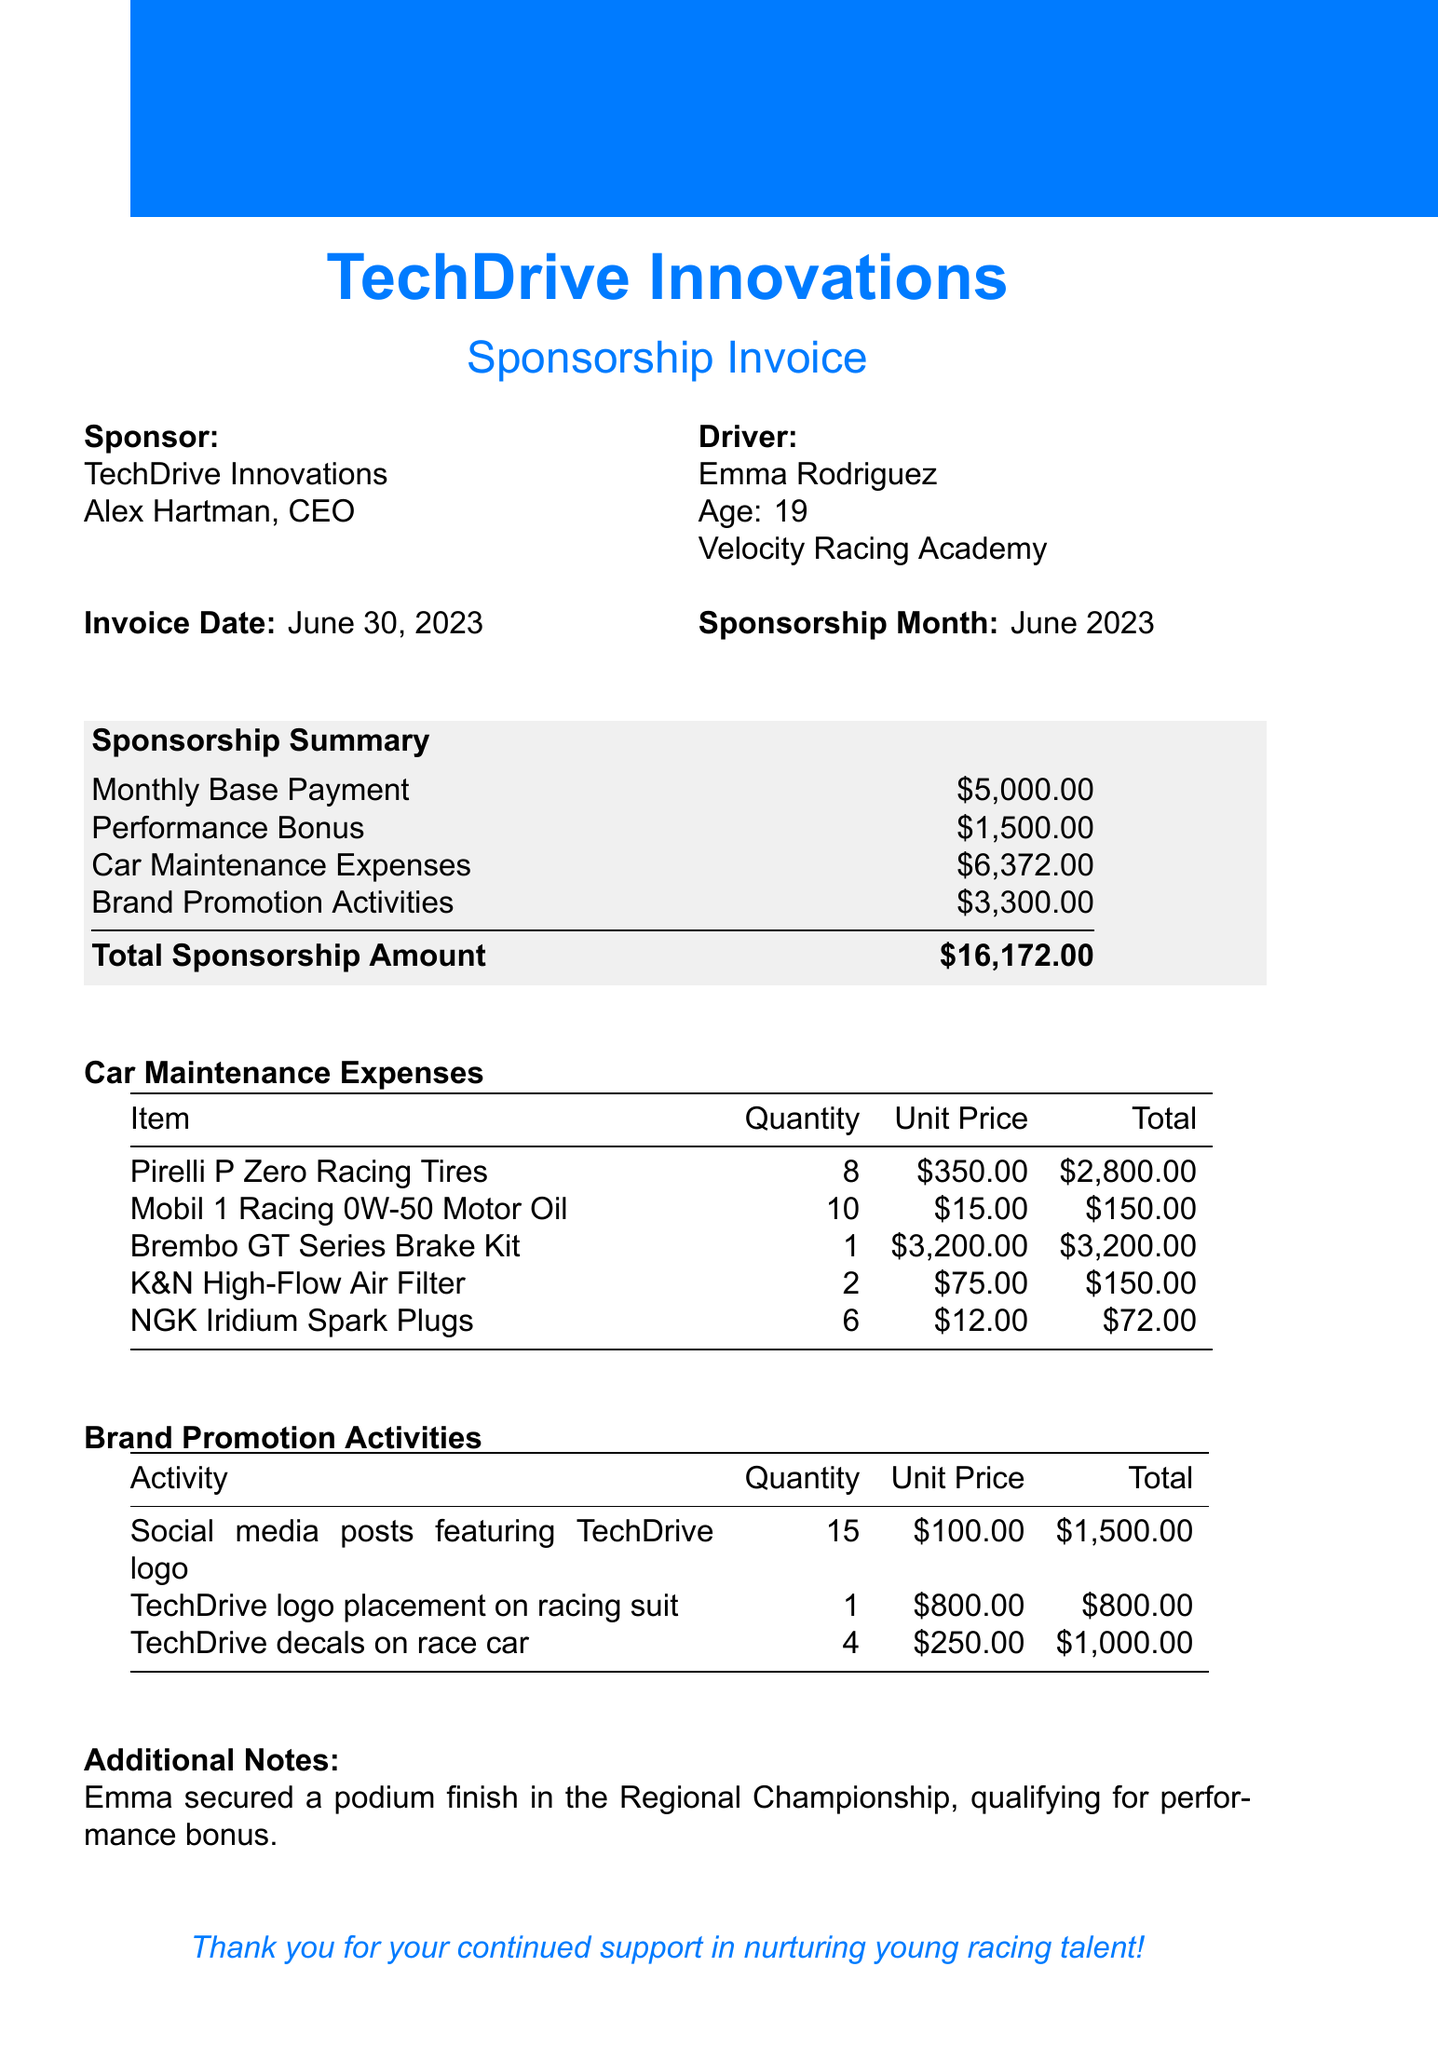What is the sponsor's name? The sponsor's name is listed at the top of the document under the title, which is TechDrive Innovations.
Answer: TechDrive Innovations Who is the young driver? The document specifies the young driver's name, which is mentioned in the introduction section.
Answer: Emma Rodriguez What is the performance bonus amount? The performance bonus is stated in the sponsorship summary and represents additional payment earned by the driver.
Answer: 1500 How many Pirelli P Zero Racing Tires were purchased? The quantity of Pirelli P Zero Racing Tires is listed under Car Maintenance Expenses in the invoice.
Answer: 8 What is the total amount for car maintenance expenses? The total for car maintenance expenses is provided in the sponsorship summary and is the sum of all individual maintenance costs.
Answer: 6372 Which brand of motor oil was used? The specific brand of motor oil is listed among the car maintenance expenses, which indicates what was purchased.
Answer: Mobil 1 Racing What activity involves TechDrive's logo placement? The activity that involves TechDrive's logo placement is detailed in the Brand Promotion Activities section of the document.
Answer: TechDrive logo placement on racing suit What is the total sponsorship amount? The total sponsorship amount is clearly stated in the sponsorship summary at the end of the invoice.
Answer: 16172 What additional note is mentioned? The additional notes section includes information about the driver's performance during the month and why they qualified for the bonus.
Answer: Emma secured a podium finish in the Regional Championship 